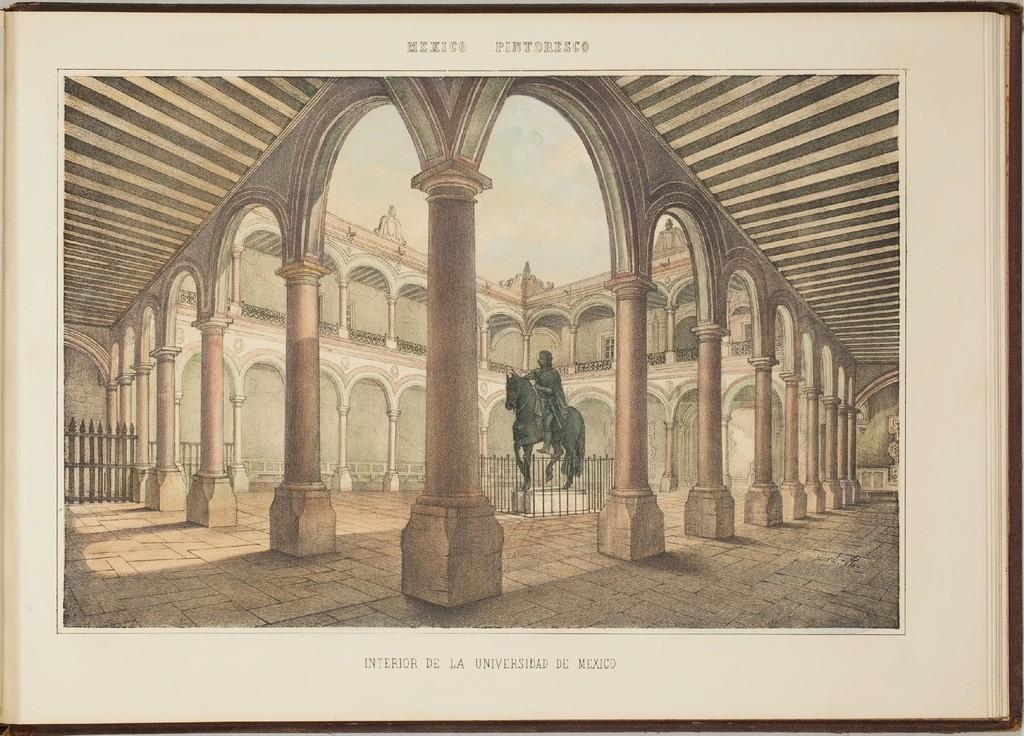What is the main subject of the photo in the image? The photo shows a palace. Are there any living creatures in the photo? Yes, there is a horse in the photo. What is the horse doing in the photo? A person is sitting on the horse. What can be seen in the sky in the photo? The sky is visible at the top of the photo. How many worms can be seen crawling on the palace in the photo? There are no worms visible in the photo; it features a palace, a horse, and a person sitting on the horse. What type of stitch is being used to sew the person's mind onto the horse in the photo? There is no mention of sewing or minds in the photo; it simply shows a person sitting on a horse in front of a palace. 